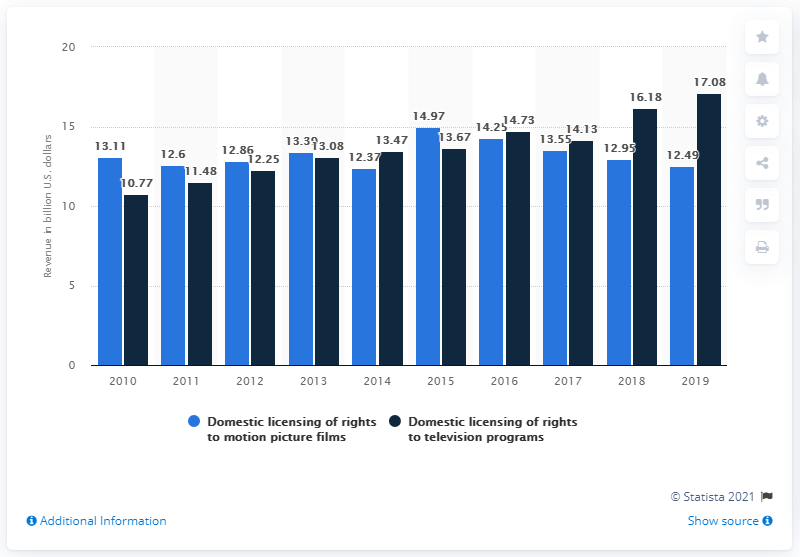Highlight a few significant elements in this photo. In 2019, the estimated revenue of the United States from domestic licensing of television programs was approximately 17.08 billion dollars. 